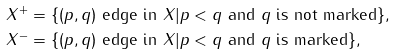<formula> <loc_0><loc_0><loc_500><loc_500>X ^ { + } & = \{ ( p , q ) \text { edge in $X$} | p < q \text { and $q$ is not marked} \} , \\ X ^ { - } & = \{ ( p , q ) \text { edge in $X$} | p < q \text { and $q$ is marked} \} ,</formula> 